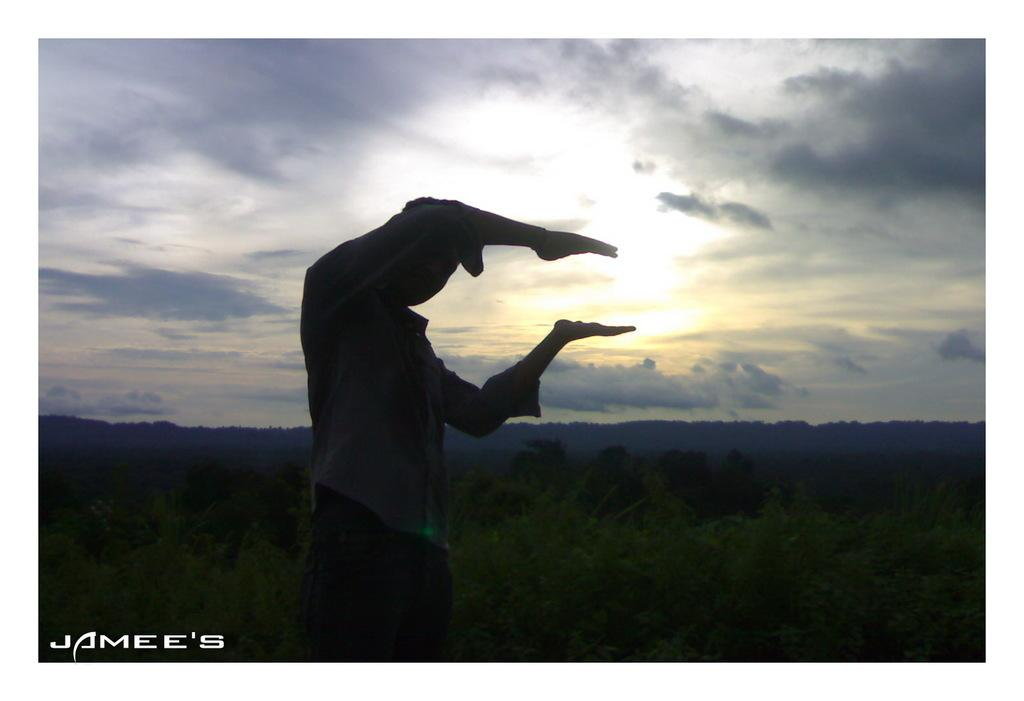What is the main subject of the image? There is a person standing in the image. What else can be seen in the image besides the person? Plants are visible in the image. What is visible in the sky in the image? There are clouds in the sky in the image. How many trucks are parked next to the person in the image? There are no trucks visible in the image. What type of string is being used by the person in the image? There is no string present in the image. 